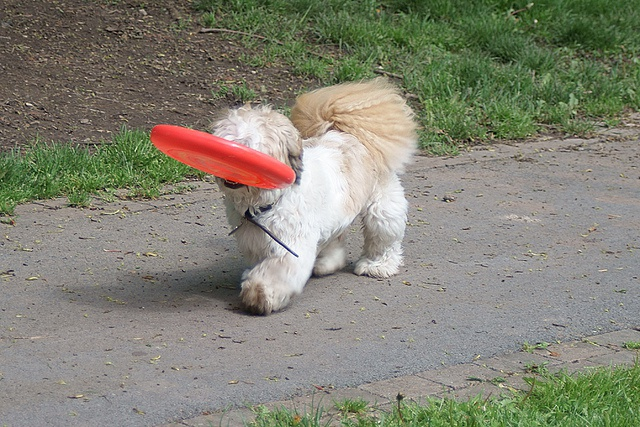Describe the objects in this image and their specific colors. I can see dog in black, lightgray, darkgray, tan, and gray tones and frisbee in black, salmon, red, and brown tones in this image. 